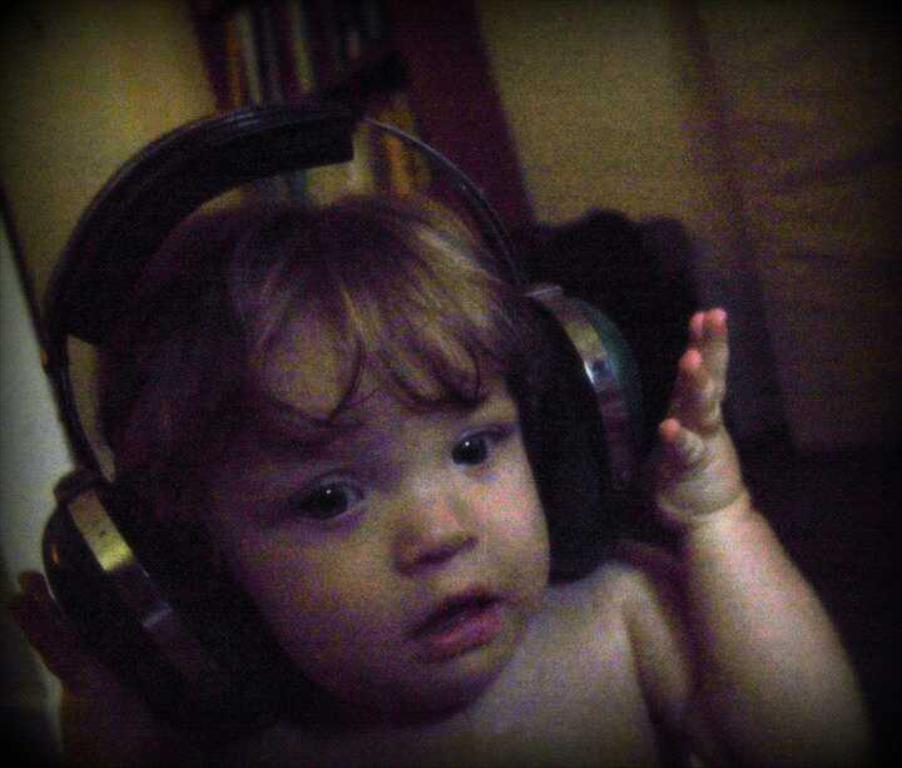What is the main subject of the image? There is a child in the image. What is the child wearing in the image? The child is wearing headphones. Can you describe the background of the image? There are objects visible in the background of the image. What type of pleasure does the child's dad experience while looking at the image? There is no information about the child's dad or their emotions in the image, so it cannot be determined. 